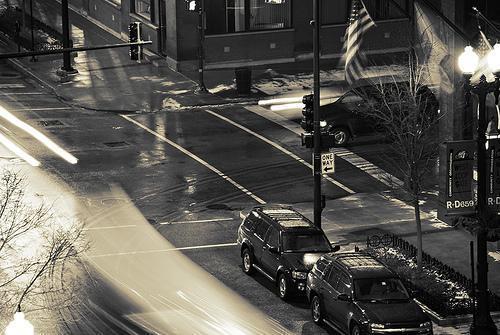How many cars are in the photo?
Give a very brief answer. 3. How many cars can you see?
Give a very brief answer. 3. 